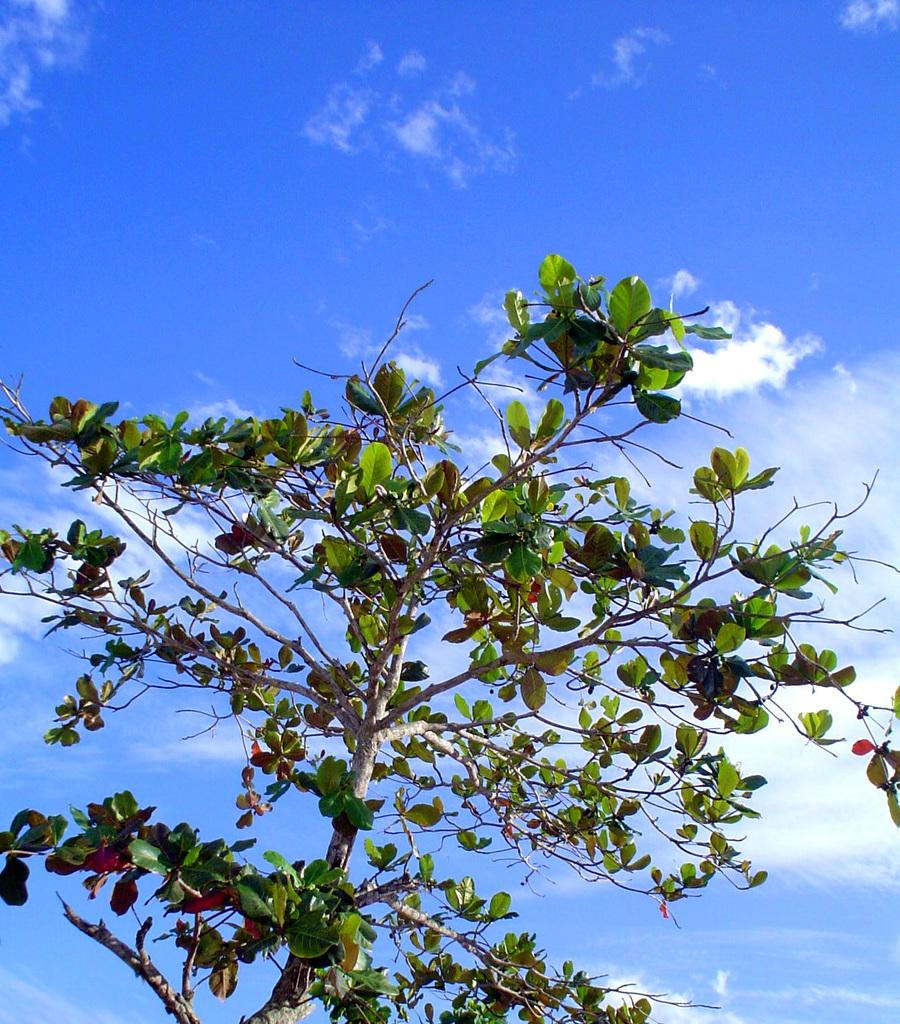What type of living organism can be seen in the image? There is a plant in the image. What color are the leaves of the plant? The plant has green leaves. What is visible in the background of the image? The sky is visible in the image. What colors can be seen in the sky? The sky has a white and blue color. Can you tell me how many guides are present in the image? There is no guide present in the image; it features a plant and the sky. What type of mass is visible in the image? There is no mass present in the image; it features a plant and the sky. 